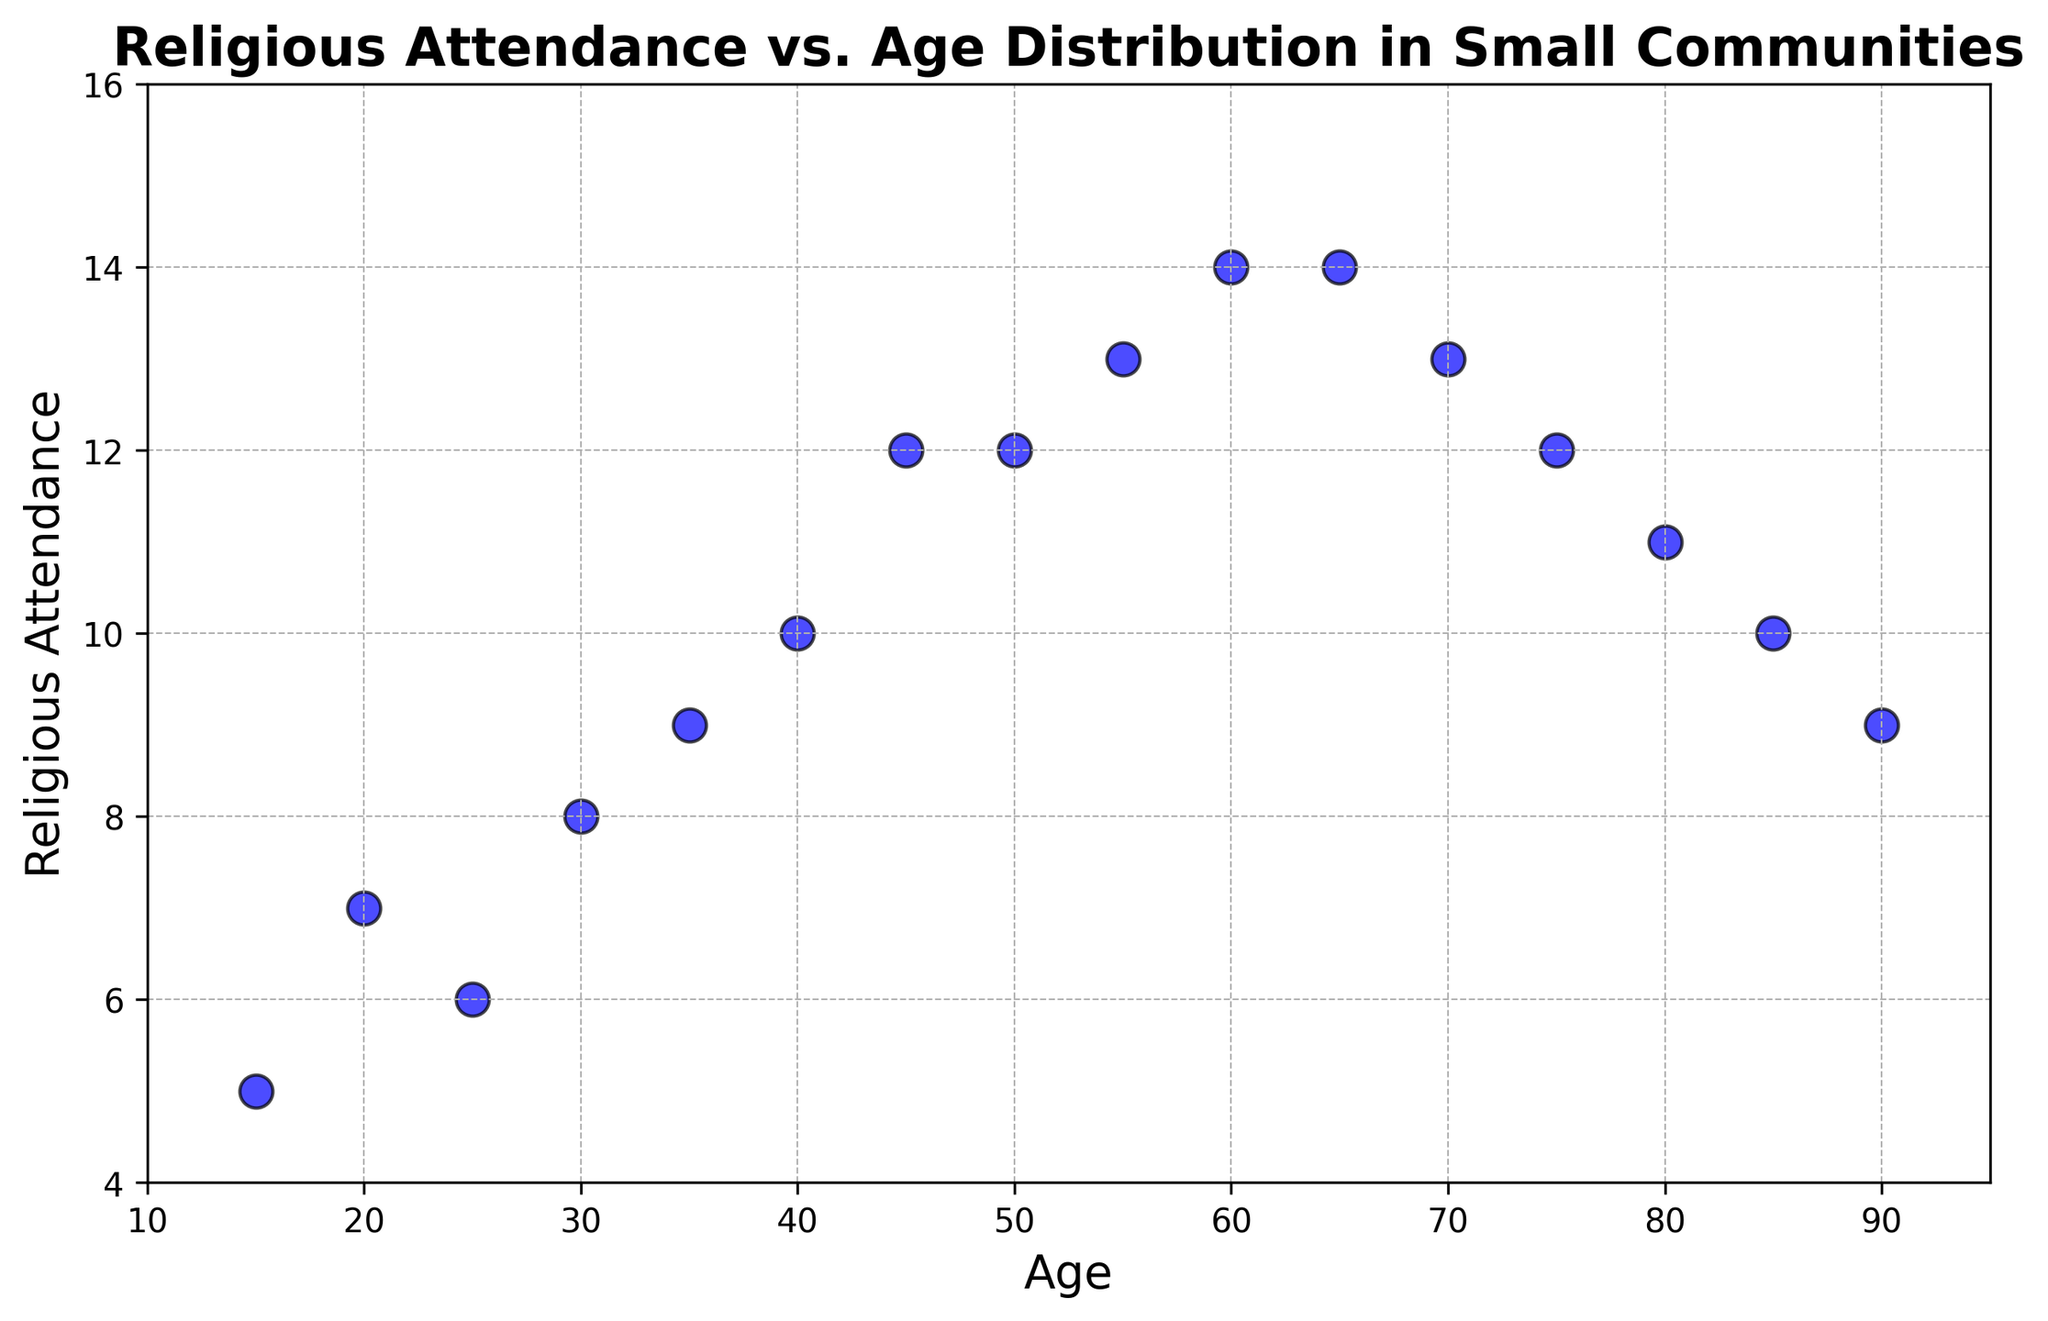What's the overall trend of religious attendance as age increases? By observing the scatter plot, we can notice that the religious attendance generally increases until around age 65, then slightly decreases. This trend suggests a peak in attendance in the older age groups.
Answer: Increases, then decreases Which age group has the highest recorded religious attendance? By looking at the scatter plot, we can see that the religious attendance is highest at ages 55 and 60, both showing a value of 14.
Answer: Ages 55 and 60 Is religious attendance more regular before or after the age of 60? Before the age of 60, religious attendance gradually increases. After 60, it becomes more irregular and generally decreases. The most consistent growth appears before 60.
Answer: Before the age of 60 Compare the religious attendance at the age of 25 and 85. The scatter plot shows that the religious attendance at the age of 25 is about 6, while at the age of 85 it is about 10. Attendance at 85 is higher than at 25.
Answer: Age 85 has higher attendance Which age groups have a religious attendance of 12 and how many such groups are there? Observing the scatter plot, the age groups with a religious attendance of 12 are 45, 50, and 75. There are three such groups.
Answer: Ages 45, 50, and 75; Three groups How does the religious attendance difference between age 15 and age 45 compare? At age 15, the religious attendance is 5, and at age 45, it is 12. The difference is 12 - 5 = 7.
Answer: 7 What can you say about the distribution of religious attendance values from ages 40 to 60? Between ages 40 and 60, the religious attendance ranges from 10 to 14, showing a steady increase and then stabilizing at the high value of 14.
Answer: Steady increase, then stabilizes Identify the age that corresponds to a religious attendance of 10. The scatter plot shows that the age groups corresponding to a religious attendance of 10 are 40 and 85.
Answer: Ages 40 and 85 What is the average religious attendance from ages 20 to 40? The religious attendance values from ages 20 to 40 are 7, 6, 8, 9, and 10. The average is calculated as (7 + 6 + 8 + 9 + 10) / 5 = 40 / 5 = 8.
Answer: 8 